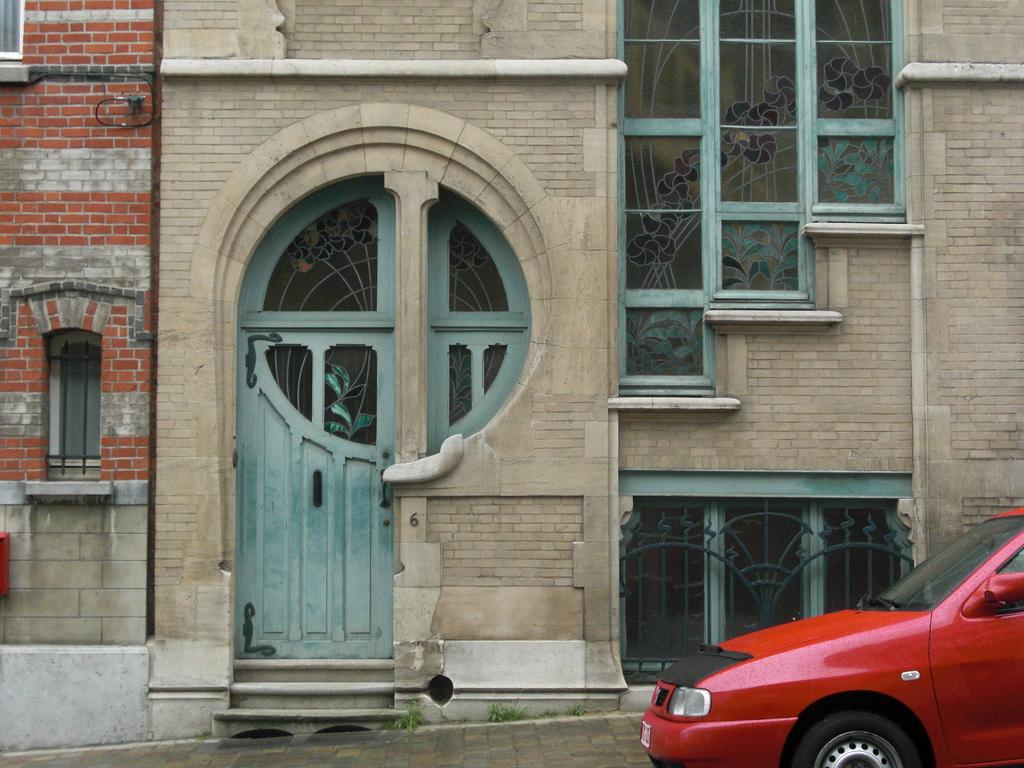What is the main subject of the image? The main subject of the image is a car. Can you describe the background of the image? There are two buildings behind the car in the image. What type of roof can be seen on the car in the image? There is no specific type of roof mentioned or visible in the image. Can you tell me how many partners are visible in the image? There are no partners present in the image; it features a car and two buildings in the background. 